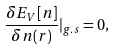Convert formula to latex. <formula><loc_0><loc_0><loc_500><loc_500>\frac { \delta E _ { V } [ n ] } { \delta n ( r ) } | _ { g . s } = 0 ,</formula> 